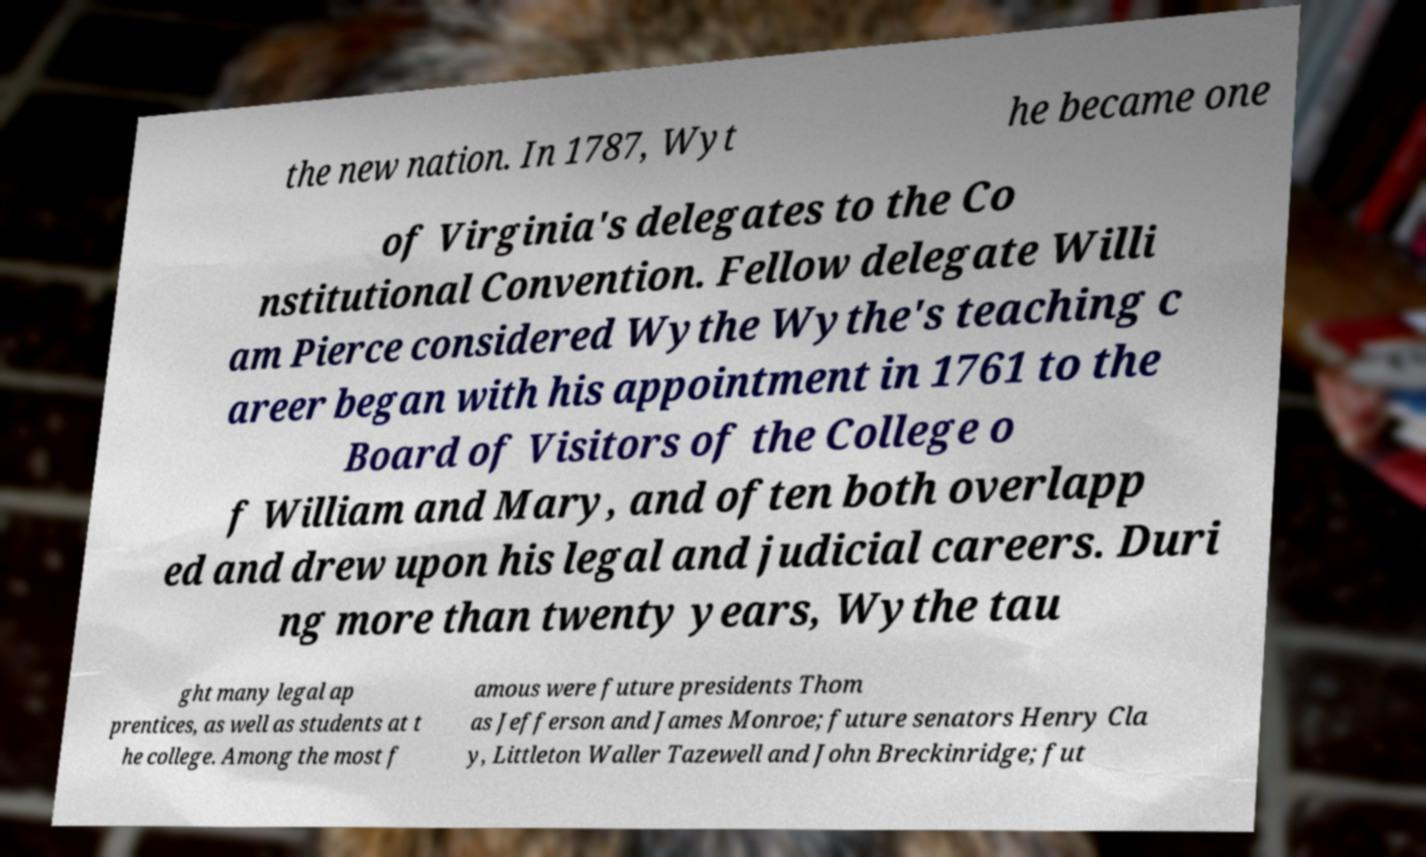Please read and relay the text visible in this image. What does it say? the new nation. In 1787, Wyt he became one of Virginia's delegates to the Co nstitutional Convention. Fellow delegate Willi am Pierce considered Wythe Wythe's teaching c areer began with his appointment in 1761 to the Board of Visitors of the College o f William and Mary, and often both overlapp ed and drew upon his legal and judicial careers. Duri ng more than twenty years, Wythe tau ght many legal ap prentices, as well as students at t he college. Among the most f amous were future presidents Thom as Jefferson and James Monroe; future senators Henry Cla y, Littleton Waller Tazewell and John Breckinridge; fut 